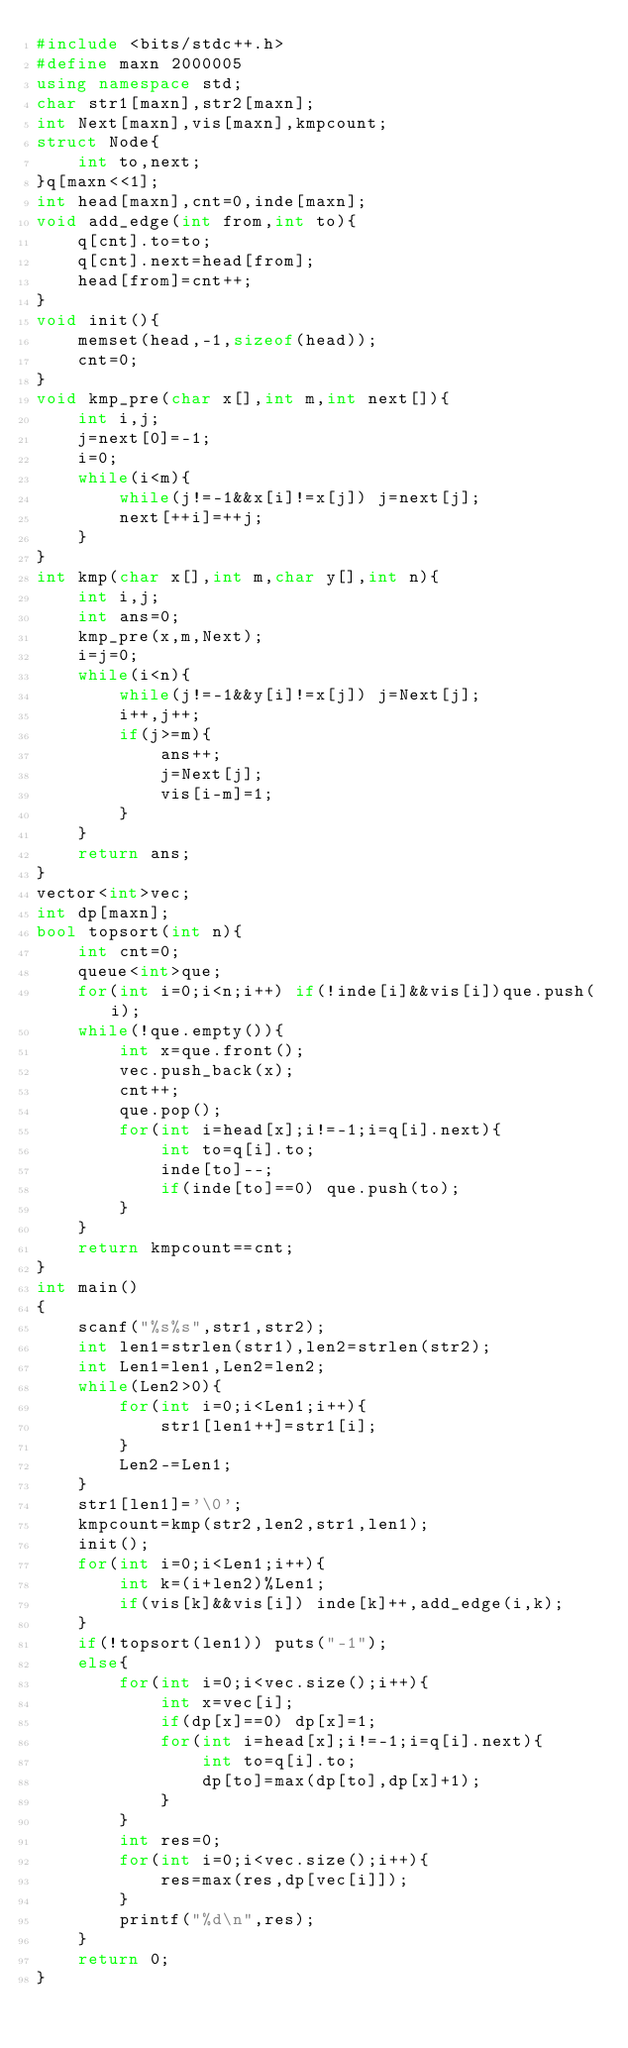<code> <loc_0><loc_0><loc_500><loc_500><_C++_>#include <bits/stdc++.h>
#define maxn 2000005
using namespace std;
char str1[maxn],str2[maxn];
int Next[maxn],vis[maxn],kmpcount;
struct Node{
    int to,next;
}q[maxn<<1];
int head[maxn],cnt=0,inde[maxn];
void add_edge(int from,int to){
    q[cnt].to=to;
    q[cnt].next=head[from];
    head[from]=cnt++;
}
void init(){
    memset(head,-1,sizeof(head));
    cnt=0;
}
void kmp_pre(char x[],int m,int next[]){
    int i,j;
    j=next[0]=-1;
    i=0;
    while(i<m){
        while(j!=-1&&x[i]!=x[j]) j=next[j];
        next[++i]=++j;
    }
}
int kmp(char x[],int m,char y[],int n){
    int i,j;
    int ans=0;
    kmp_pre(x,m,Next);
    i=j=0;
    while(i<n){
        while(j!=-1&&y[i]!=x[j]) j=Next[j];
        i++,j++;
        if(j>=m){
            ans++;
            j=Next[j];
            vis[i-m]=1;
        }
    }
    return ans;
}
vector<int>vec;
int dp[maxn];
bool topsort(int n){
    int cnt=0;
    queue<int>que;
    for(int i=0;i<n;i++) if(!inde[i]&&vis[i])que.push(i);
    while(!que.empty()){
        int x=que.front();
        vec.push_back(x);
        cnt++;
        que.pop();
        for(int i=head[x];i!=-1;i=q[i].next){
            int to=q[i].to;
            inde[to]--;
            if(inde[to]==0) que.push(to);
        }
    }
    return kmpcount==cnt;
}
int main()
{
    scanf("%s%s",str1,str2);
    int len1=strlen(str1),len2=strlen(str2);
    int Len1=len1,Len2=len2;
    while(Len2>0){
        for(int i=0;i<Len1;i++){
            str1[len1++]=str1[i];
        }
        Len2-=Len1;
    }
    str1[len1]='\0';
    kmpcount=kmp(str2,len2,str1,len1);
    init();
    for(int i=0;i<Len1;i++){
        int k=(i+len2)%Len1;
        if(vis[k]&&vis[i]) inde[k]++,add_edge(i,k);
    }
    if(!topsort(len1)) puts("-1");
    else{
        for(int i=0;i<vec.size();i++){
            int x=vec[i];
            if(dp[x]==0) dp[x]=1;
            for(int i=head[x];i!=-1;i=q[i].next){
                int to=q[i].to;
                dp[to]=max(dp[to],dp[x]+1);
            }
        }
        int res=0;
        for(int i=0;i<vec.size();i++){
            res=max(res,dp[vec[i]]);
        }
        printf("%d\n",res);
    }
    return 0;
}
</code> 